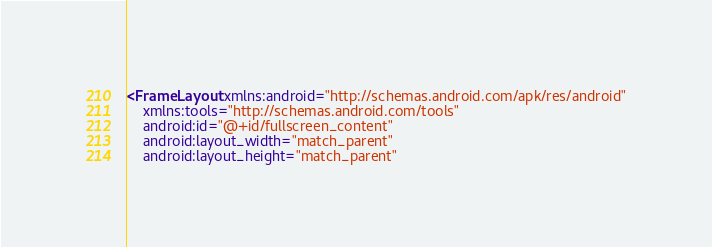<code> <loc_0><loc_0><loc_500><loc_500><_XML_><FrameLayout xmlns:android="http://schemas.android.com/apk/res/android"
    xmlns:tools="http://schemas.android.com/tools"
    android:id="@+id/fullscreen_content"
    android:layout_width="match_parent"
    android:layout_height="match_parent"</code> 